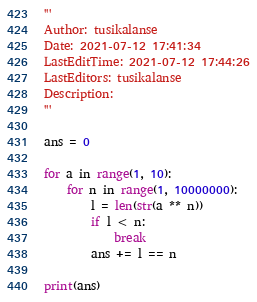<code> <loc_0><loc_0><loc_500><loc_500><_Python_>'''
Author: tusikalanse
Date: 2021-07-12 17:41:34
LastEditTime: 2021-07-12 17:44:26
LastEditors: tusikalanse
Description: 
'''

ans = 0

for a in range(1, 10):
    for n in range(1, 10000000):
        l = len(str(a ** n))
        if l < n:
            break
        ans += l == n

print(ans)
</code> 